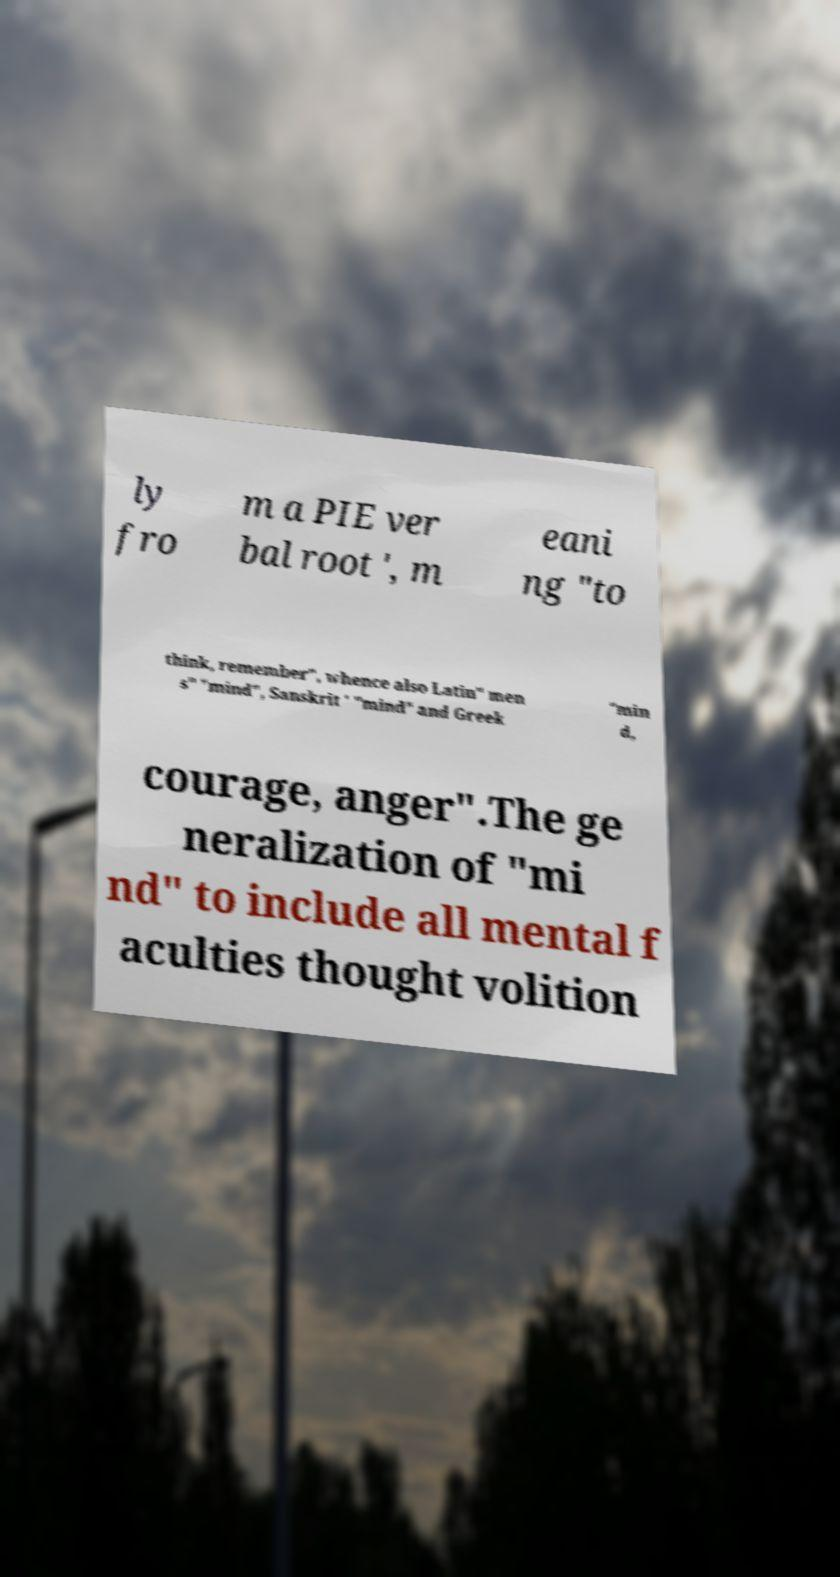I need the written content from this picture converted into text. Can you do that? ly fro m a PIE ver bal root ', m eani ng "to think, remember", whence also Latin" men s" "mind", Sanskrit ' "mind" and Greek "min d, courage, anger".The ge neralization of "mi nd" to include all mental f aculties thought volition 